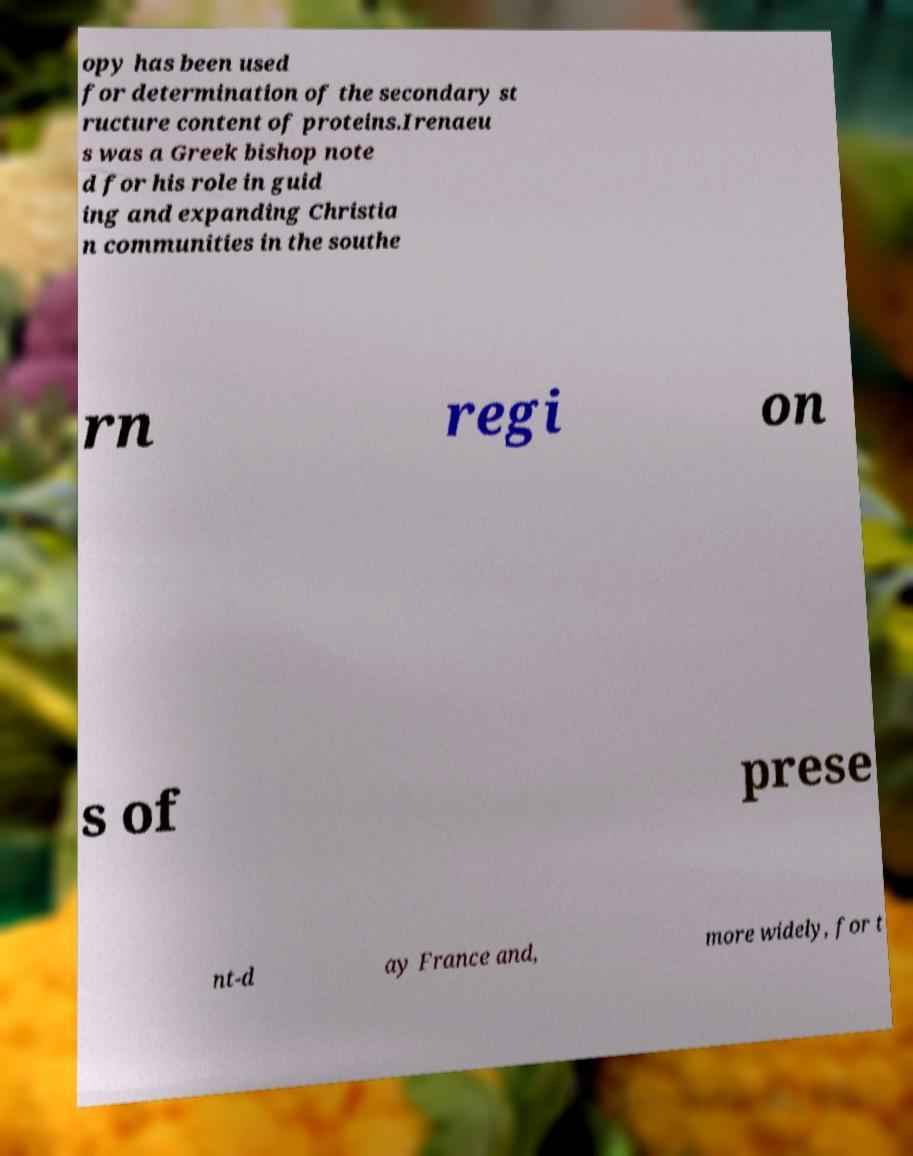Please identify and transcribe the text found in this image. opy has been used for determination of the secondary st ructure content of proteins.Irenaeu s was a Greek bishop note d for his role in guid ing and expanding Christia n communities in the southe rn regi on s of prese nt-d ay France and, more widely, for t 